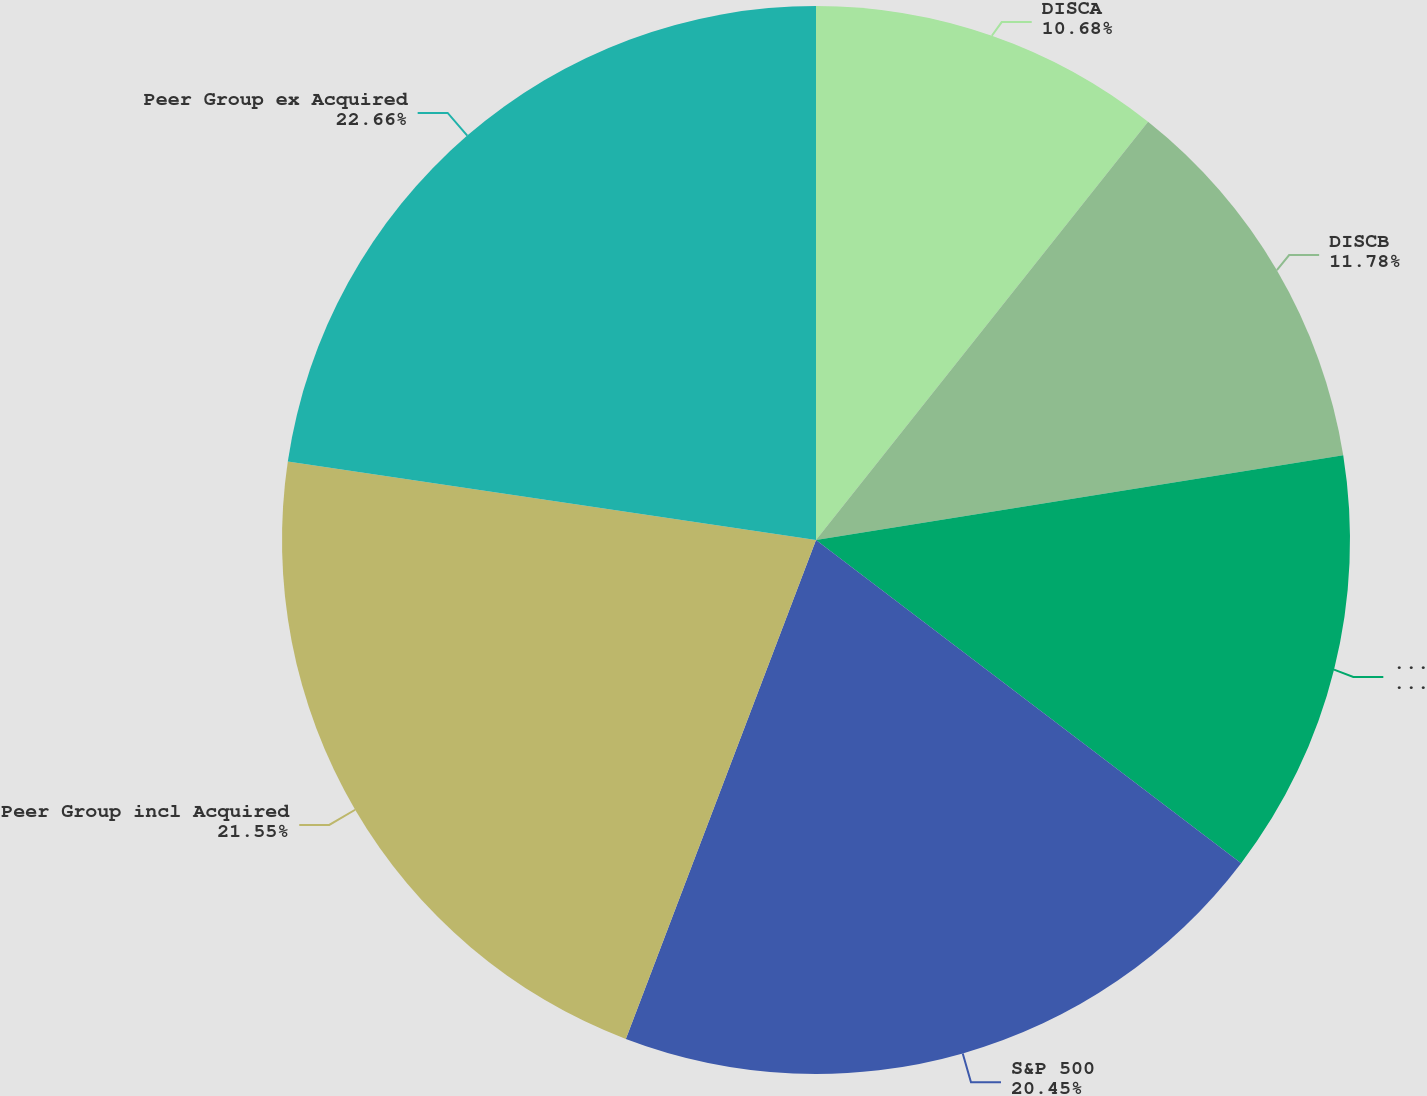Convert chart. <chart><loc_0><loc_0><loc_500><loc_500><pie_chart><fcel>DISCA<fcel>DISCB<fcel>DISCK<fcel>S&P 500<fcel>Peer Group incl Acquired<fcel>Peer Group ex Acquired<nl><fcel>10.68%<fcel>11.78%<fcel>12.88%<fcel>20.45%<fcel>21.55%<fcel>22.65%<nl></chart> 